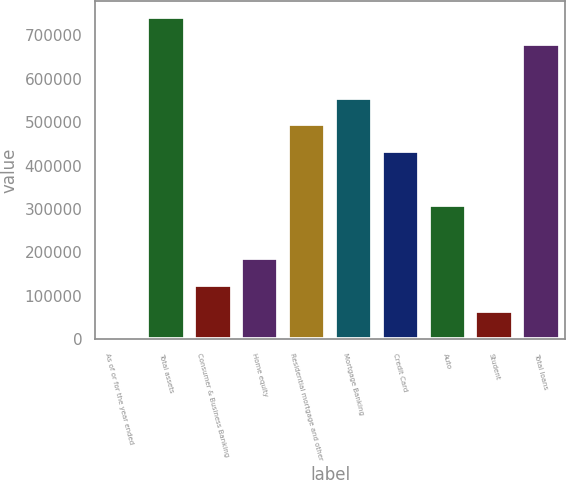Convert chart to OTSL. <chart><loc_0><loc_0><loc_500><loc_500><bar_chart><fcel>As of or for the year ended<fcel>Total assets<fcel>Consumer & Business Banking<fcel>Home equity<fcel>Residential mortgage and other<fcel>Mortgage Banking<fcel>Credit Card<fcel>Auto<fcel>Student<fcel>Total loans<nl><fcel>2016<fcel>741601<fcel>125280<fcel>186912<fcel>495073<fcel>556705<fcel>433441<fcel>310176<fcel>63648.1<fcel>679969<nl></chart> 